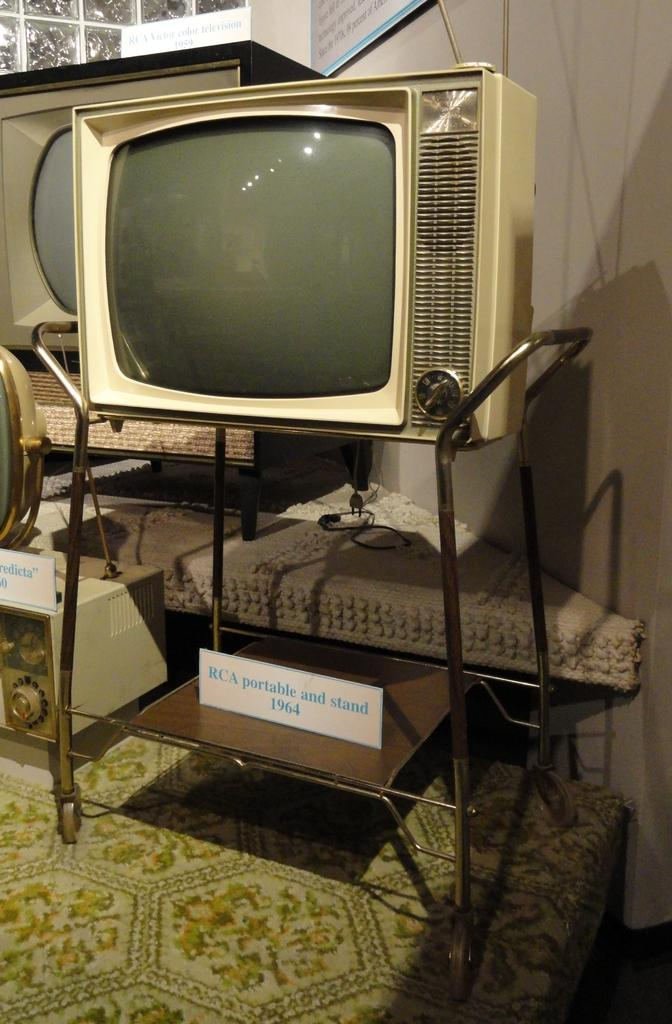<image>
Provide a brief description of the given image. An old fashioned TV has the date 1964 on it. 